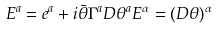Convert formula to latex. <formula><loc_0><loc_0><loc_500><loc_500>E ^ { a } = e ^ { a } + i \bar { \theta } \Gamma ^ { a } D \theta ^ { a } E ^ { \alpha } = ( D \theta ) ^ { \alpha }</formula> 